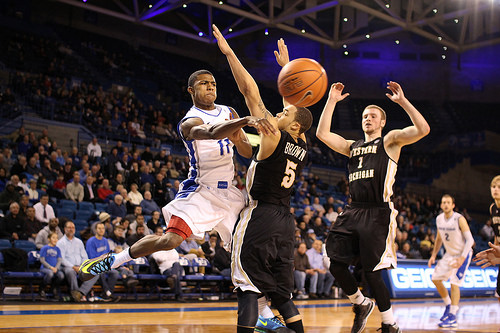<image>
Can you confirm if the jersey is on the person? No. The jersey is not positioned on the person. They may be near each other, but the jersey is not supported by or resting on top of the person. 